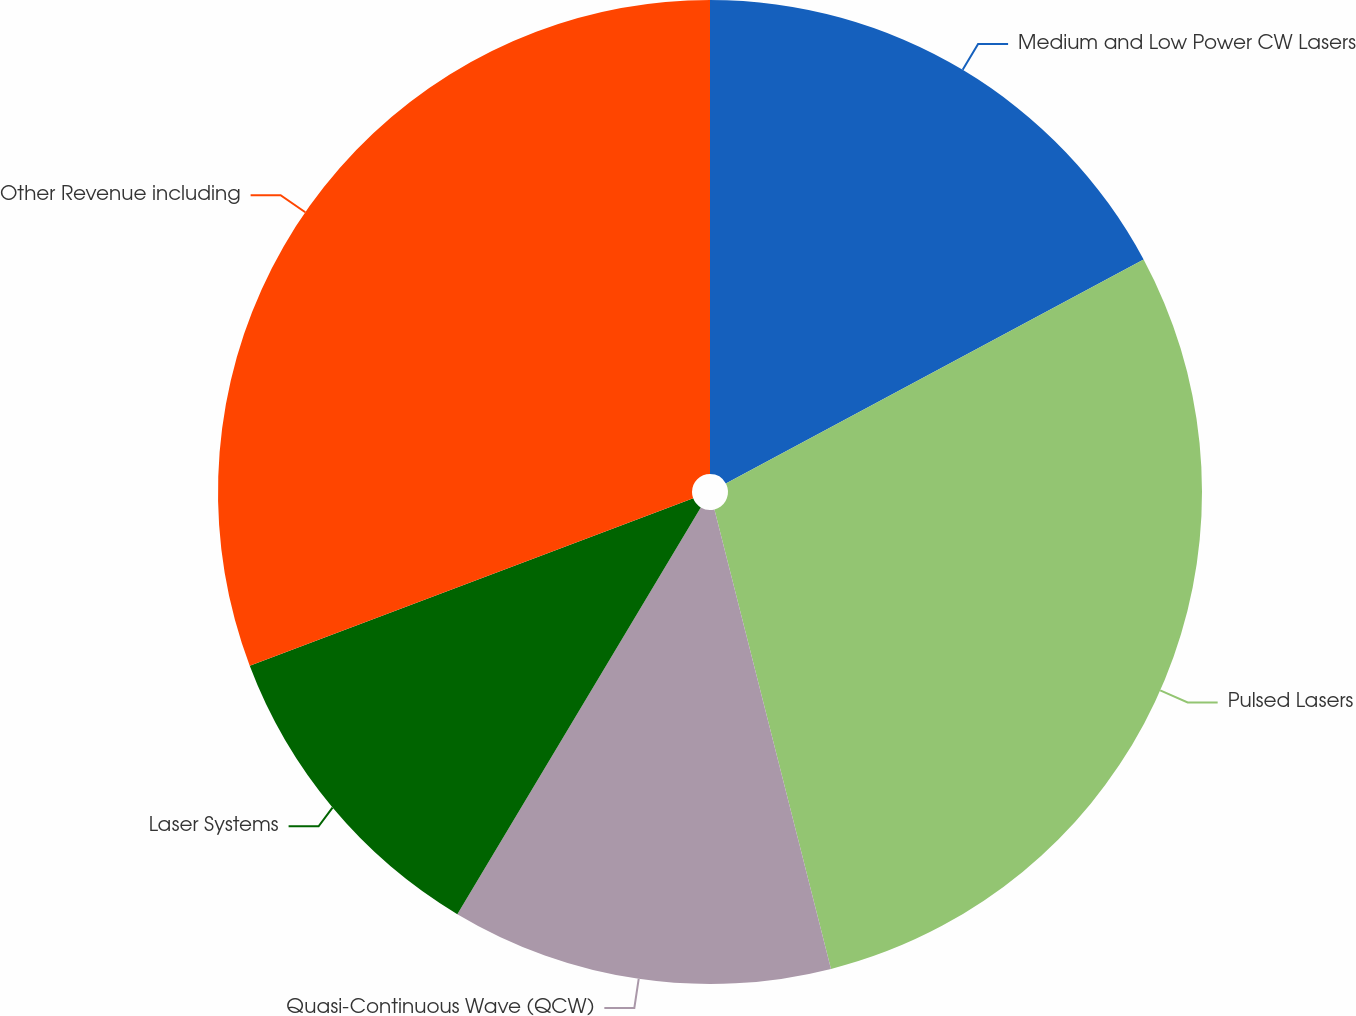Convert chart to OTSL. <chart><loc_0><loc_0><loc_500><loc_500><pie_chart><fcel>Medium and Low Power CW Lasers<fcel>Pulsed Lasers<fcel>Quasi-Continuous Wave (QCW)<fcel>Laser Systems<fcel>Other Revenue including<nl><fcel>17.17%<fcel>28.88%<fcel>12.54%<fcel>10.67%<fcel>30.75%<nl></chart> 